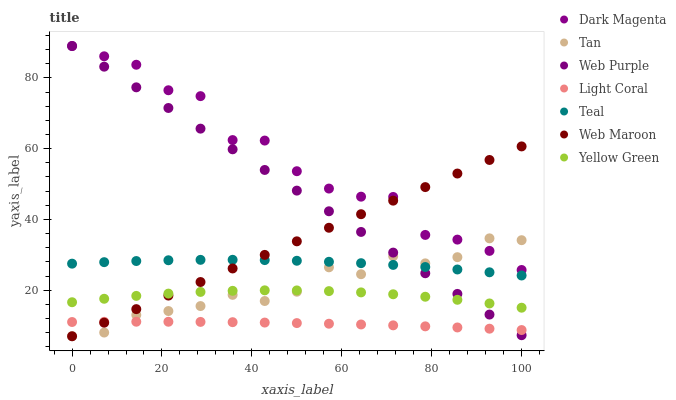Does Light Coral have the minimum area under the curve?
Answer yes or no. Yes. Does Dark Magenta have the maximum area under the curve?
Answer yes or no. Yes. Does Web Maroon have the minimum area under the curve?
Answer yes or no. No. Does Web Maroon have the maximum area under the curve?
Answer yes or no. No. Is Web Maroon the smoothest?
Answer yes or no. Yes. Is Dark Magenta the roughest?
Answer yes or no. Yes. Is Light Coral the smoothest?
Answer yes or no. No. Is Light Coral the roughest?
Answer yes or no. No. Does Web Maroon have the lowest value?
Answer yes or no. Yes. Does Light Coral have the lowest value?
Answer yes or no. No. Does Web Purple have the highest value?
Answer yes or no. Yes. Does Web Maroon have the highest value?
Answer yes or no. No. Is Light Coral less than Yellow Green?
Answer yes or no. Yes. Is Yellow Green greater than Light Coral?
Answer yes or no. Yes. Does Web Maroon intersect Web Purple?
Answer yes or no. Yes. Is Web Maroon less than Web Purple?
Answer yes or no. No. Is Web Maroon greater than Web Purple?
Answer yes or no. No. Does Light Coral intersect Yellow Green?
Answer yes or no. No. 